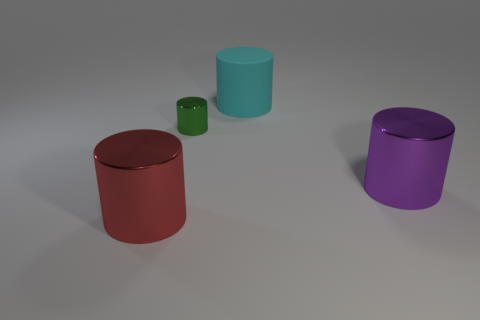What number of other objects are there of the same size as the matte cylinder?
Keep it short and to the point. 2. What is the color of the big object that is in front of the cylinder that is right of the cyan rubber cylinder?
Your response must be concise. Red. How many other objects are there of the same shape as the large cyan rubber object?
Your response must be concise. 3. Are there any large red cylinders that have the same material as the purple cylinder?
Offer a very short reply. Yes. There is a purple object that is the same size as the red metallic cylinder; what is it made of?
Offer a terse response. Metal. The big metal thing behind the big metal object that is in front of the big metal object to the right of the big rubber cylinder is what color?
Your response must be concise. Purple. There is a big cyan object that is right of the green object; is its shape the same as the large metal object right of the large rubber cylinder?
Provide a succinct answer. Yes. How many red cylinders are there?
Make the answer very short. 1. There is another metal object that is the same size as the purple thing; what color is it?
Your answer should be compact. Red. Do the object behind the green metal thing and the thing that is left of the tiny green metal cylinder have the same material?
Provide a short and direct response. No. 